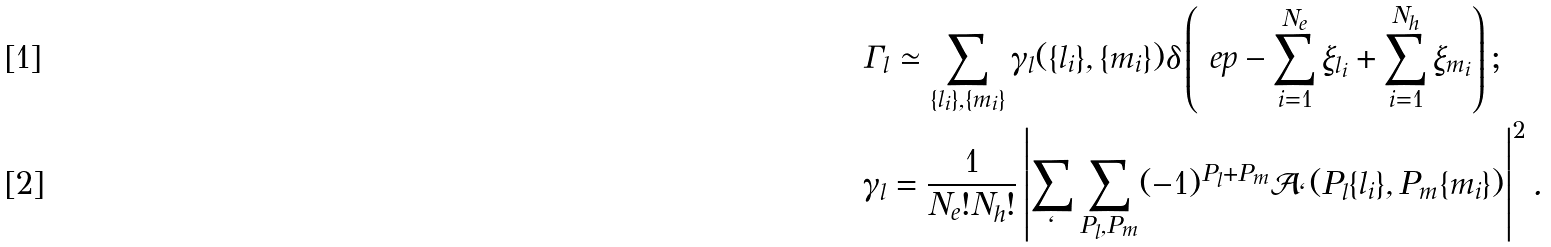<formula> <loc_0><loc_0><loc_500><loc_500>& \Gamma _ { l } \simeq \sum _ { \{ l _ { i } \} , \{ m _ { i } \} } \gamma _ { l } ( \{ l _ { i } \} , \{ m _ { i } \} ) \delta \left ( \ e p - \sum _ { i = 1 } ^ { N _ { e } } \xi _ { l _ { i } } + \sum _ { i = 1 } ^ { N _ { h } } \xi _ { m _ { i } } \right ) ; \\ & \gamma _ { l } = \frac { 1 } { N _ { e } ! N _ { h } ! } \left | \sum _ { \ell } \sum _ { P _ { l } , P _ { m } } ( - 1 ) ^ { P _ { l } + P _ { m } } \mathcal { A } _ { \ell } ( P _ { l } \{ l _ { i } \} , P _ { m } \{ m _ { i } \} ) \right | ^ { 2 } .</formula> 